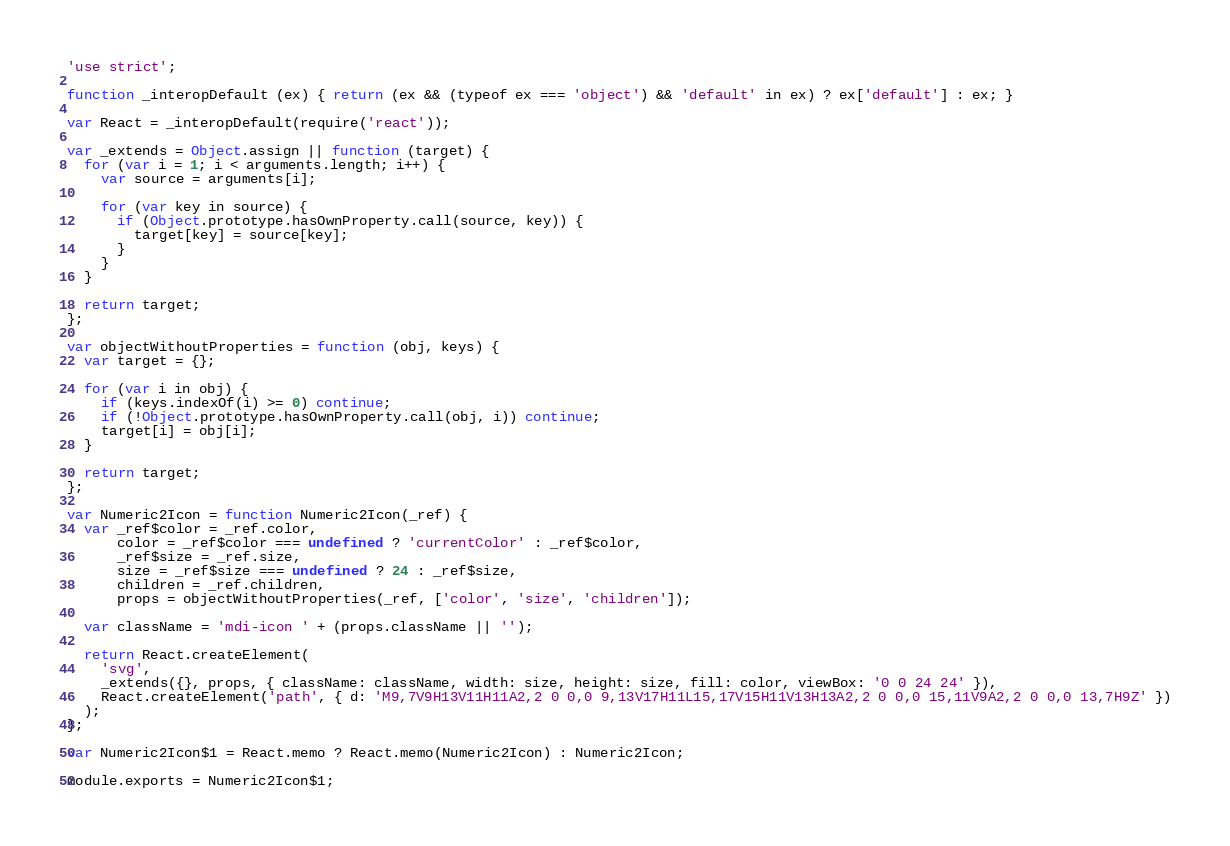Convert code to text. <code><loc_0><loc_0><loc_500><loc_500><_JavaScript_>'use strict';

function _interopDefault (ex) { return (ex && (typeof ex === 'object') && 'default' in ex) ? ex['default'] : ex; }

var React = _interopDefault(require('react'));

var _extends = Object.assign || function (target) {
  for (var i = 1; i < arguments.length; i++) {
    var source = arguments[i];

    for (var key in source) {
      if (Object.prototype.hasOwnProperty.call(source, key)) {
        target[key] = source[key];
      }
    }
  }

  return target;
};

var objectWithoutProperties = function (obj, keys) {
  var target = {};

  for (var i in obj) {
    if (keys.indexOf(i) >= 0) continue;
    if (!Object.prototype.hasOwnProperty.call(obj, i)) continue;
    target[i] = obj[i];
  }

  return target;
};

var Numeric2Icon = function Numeric2Icon(_ref) {
  var _ref$color = _ref.color,
      color = _ref$color === undefined ? 'currentColor' : _ref$color,
      _ref$size = _ref.size,
      size = _ref$size === undefined ? 24 : _ref$size,
      children = _ref.children,
      props = objectWithoutProperties(_ref, ['color', 'size', 'children']);

  var className = 'mdi-icon ' + (props.className || '');

  return React.createElement(
    'svg',
    _extends({}, props, { className: className, width: size, height: size, fill: color, viewBox: '0 0 24 24' }),
    React.createElement('path', { d: 'M9,7V9H13V11H11A2,2 0 0,0 9,13V17H11L15,17V15H11V13H13A2,2 0 0,0 15,11V9A2,2 0 0,0 13,7H9Z' })
  );
};

var Numeric2Icon$1 = React.memo ? React.memo(Numeric2Icon) : Numeric2Icon;

module.exports = Numeric2Icon$1;
</code> 